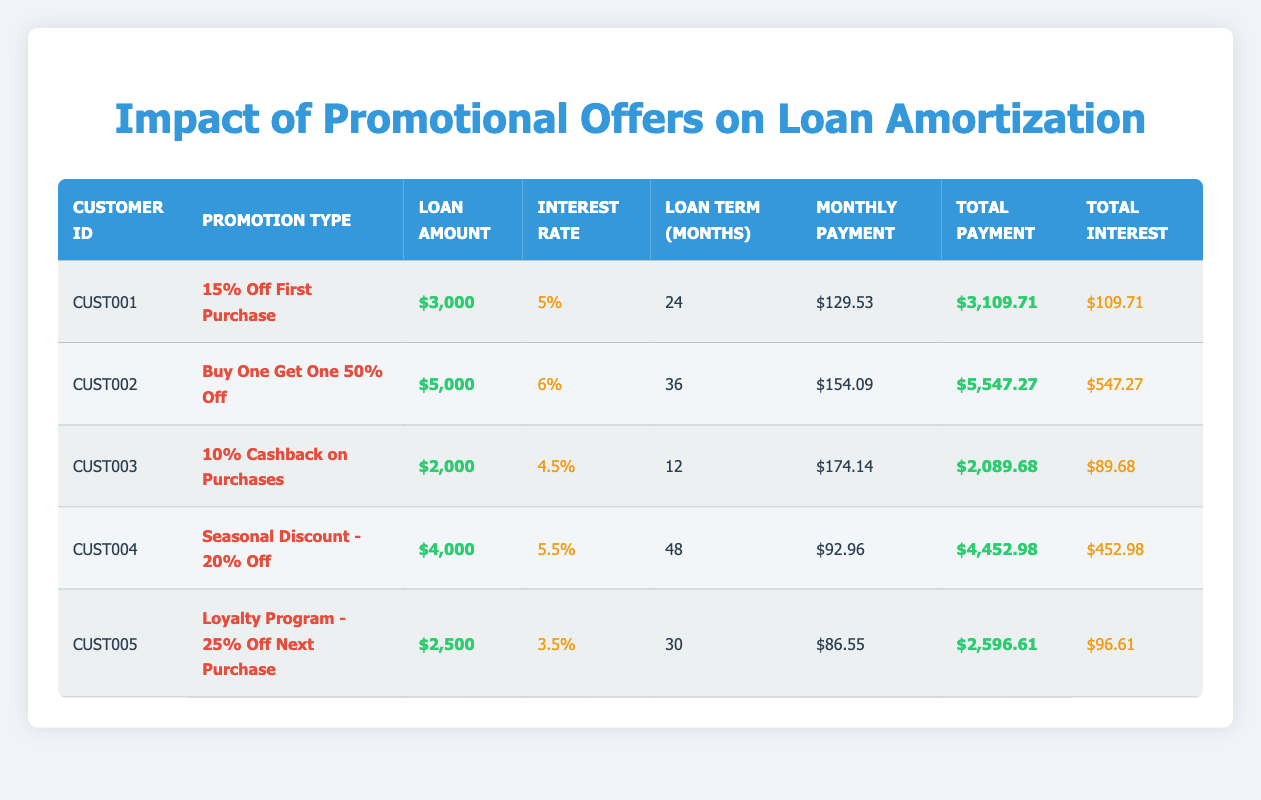What is the loan amount for customer CUST002? The table shows that customer CUST002 has a loan amount listed under the "Loan Amount" column. Referring to the row for CUST002, the loan amount is $5,000.
Answer: $5,000 What is the total payment made by customer CUST004? Looking at the row for customer CUST004 in the table, the "Total Payment" column indicates that the total payment is $4,452.98.
Answer: $4,452.98 Which promotion offers the highest monthly payment? To determine the highest monthly payment, we look at the "Monthly Payment" column for all customers. The maximum monthly payment of $174.14 belongs to customer CUST003 under the "10% Cashback on Purchases" promotion.
Answer: 10% Cashback on Purchases What is the average total interest paid across all customers in the table? We can find the total interest paid by each customer from the "Total Interest" column: 109.71 + 547.27 + 89.68 + 452.98 + 96.61 = 1296.25. There are 5 customers, thus the average total interest is 1296.25 / 5 = 259.25.
Answer: 259.25 Does customer CUST005 have a lower interest rate than customer CUST001? By comparing the "Interest Rate" values, CUST005 has an interest rate of 3.5%, while CUST001 has an interest rate of 5%. Since 3.5% is less than 5%, the answer is yes.
Answer: Yes What is the total payment difference between customers CUST001 and CUST002? The total payment for CUST001 is $3,109.71 and for CUST002 is $5,547.27. To find the difference, we subtract CUST001's total payment from CUST002's total payment: 5,547.27 - 3,109.71 = 2,437.56.
Answer: $2,437.56 Is the loan term for customer CUST003 shorter than that for customer CUST005? Customer CUST003 has a loan term of 12 months, while CUST005 has a loan term of 30 months. Since 12 months is less than 30 months, the answer is yes.
Answer: Yes How many promotional offers result in total payments greater than $4,000? We analyze the "Total Payment" column: CUST002: $5,547.27, CUST004: $4,452.98. Only these two offers exceed $4,000. Hence, there are 2 promotional offers that result in total payments greater than $4,000.
Answer: 2 What is the monthly payment of the customer who received the highest interest rate? The highest interest rate in the table is 6% for customer CUST002. Referring to the same row, the "Monthly Payment" for CUST002 is $154.09.
Answer: $154.09 